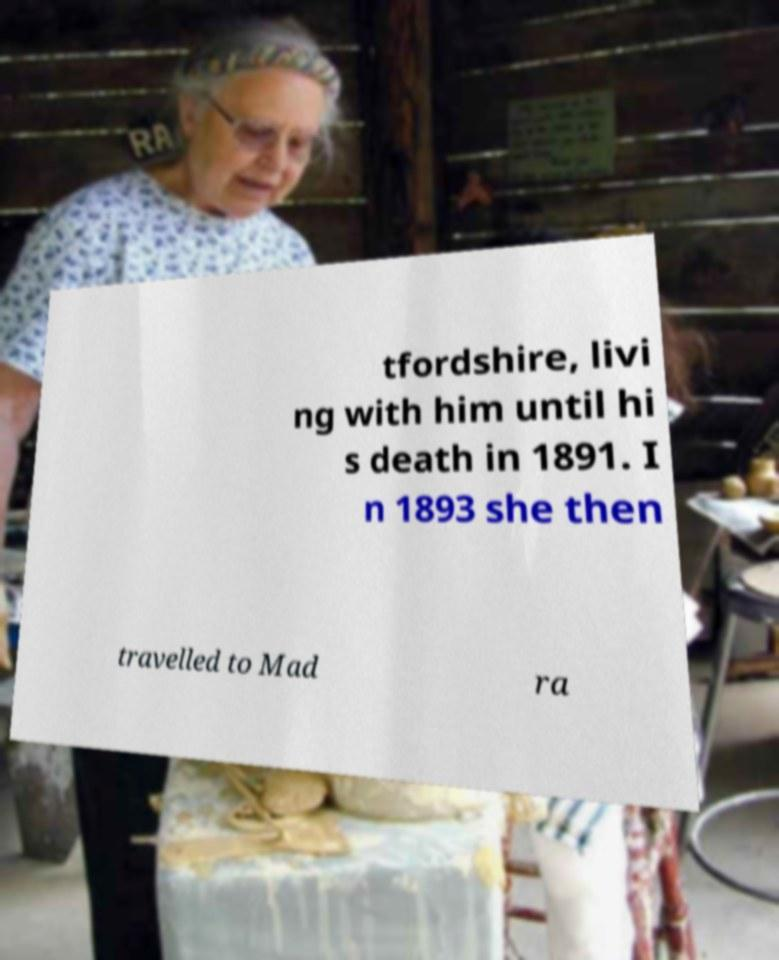Please identify and transcribe the text found in this image. tfordshire, livi ng with him until hi s death in 1891. I n 1893 she then travelled to Mad ra 